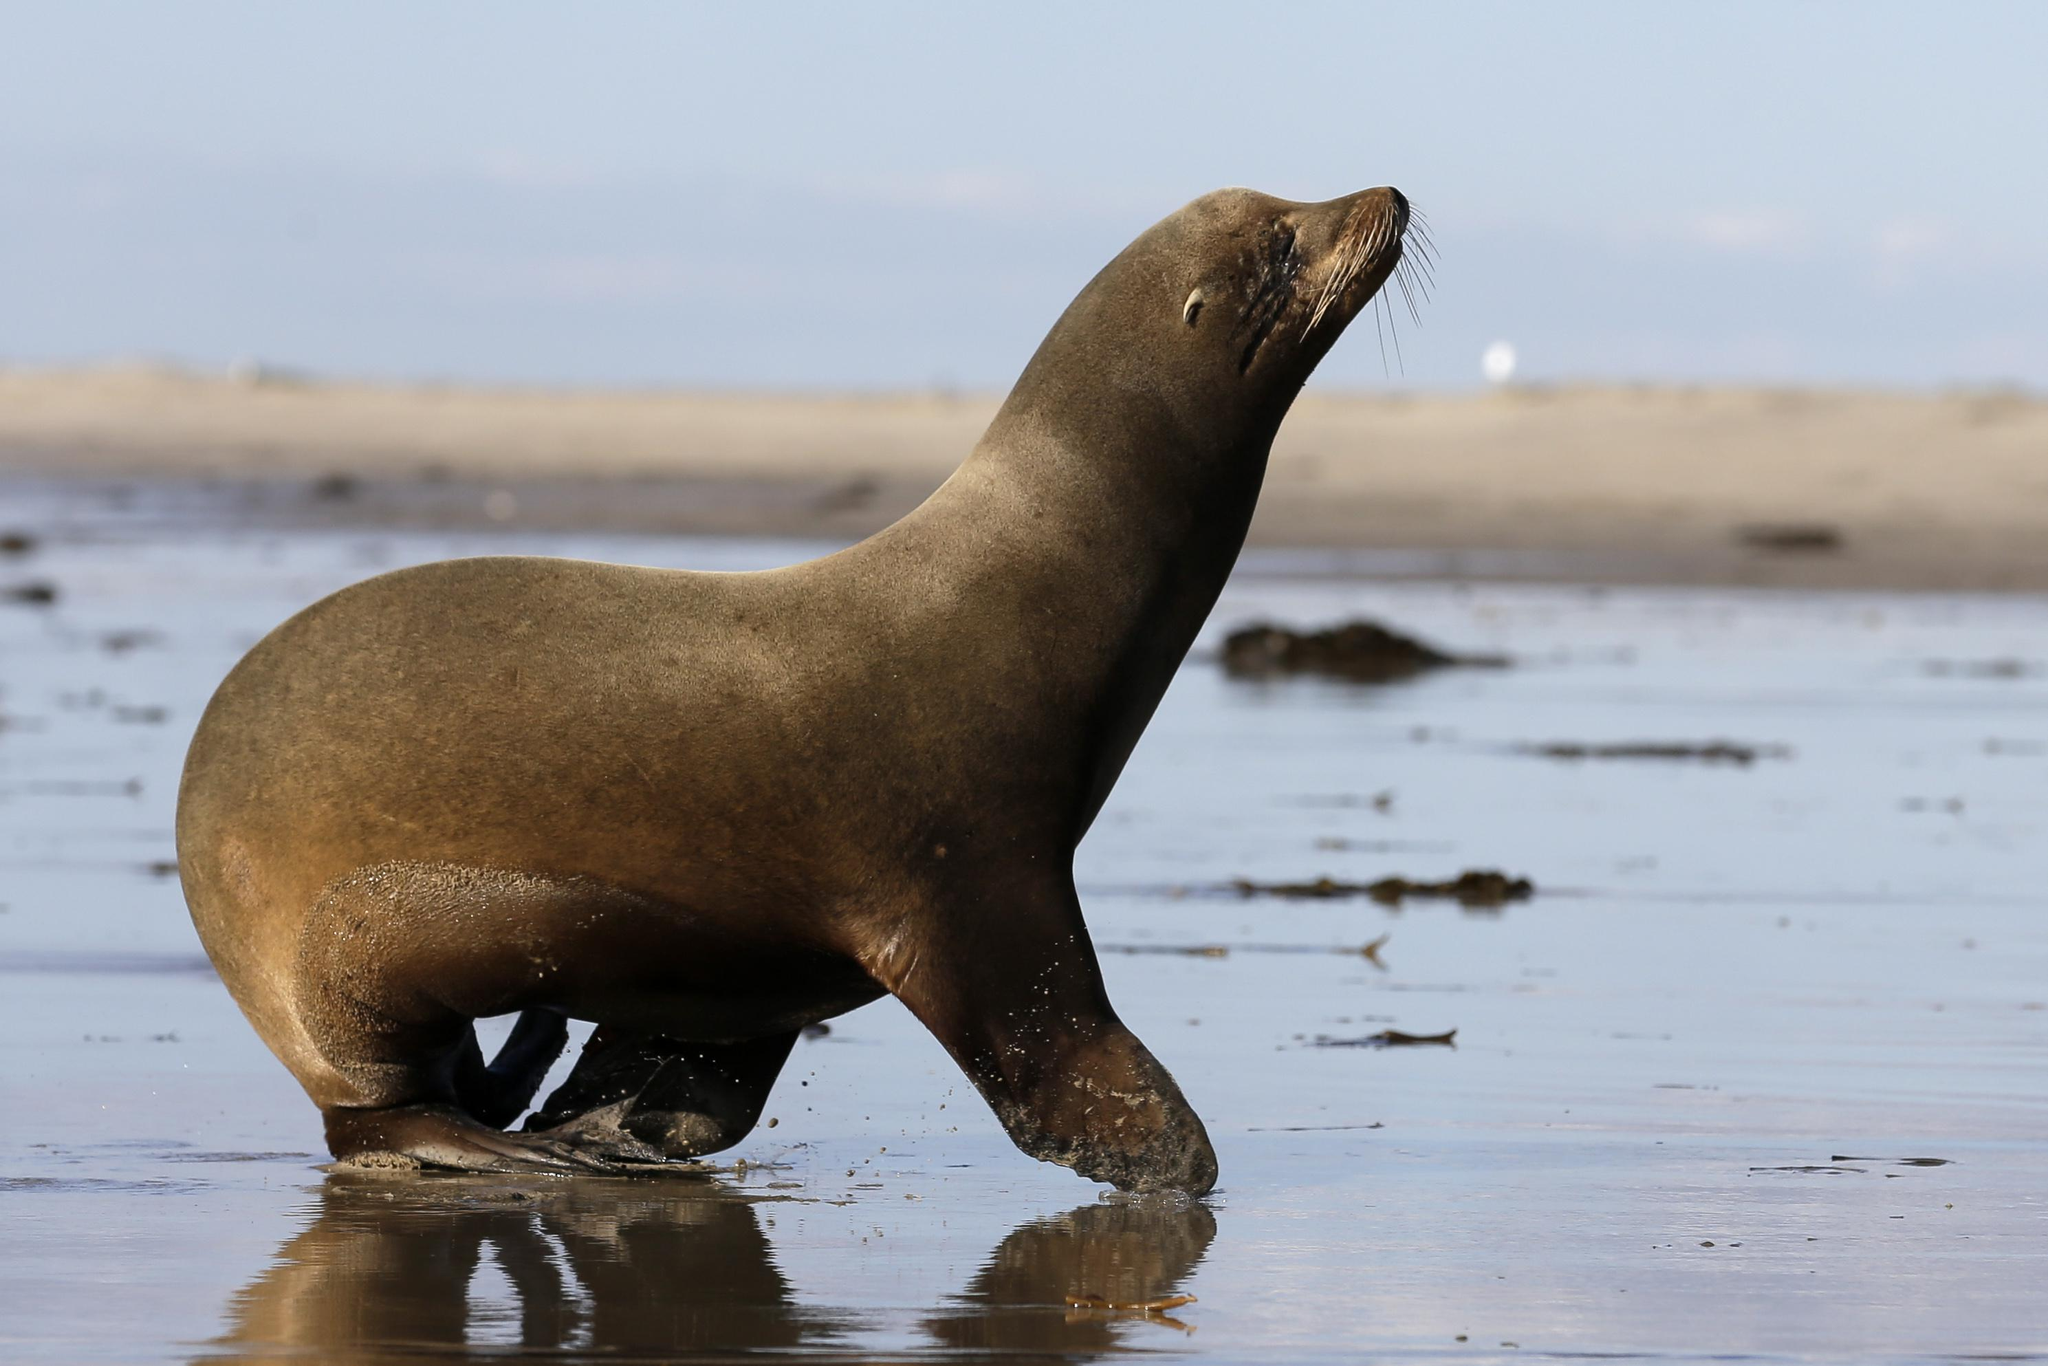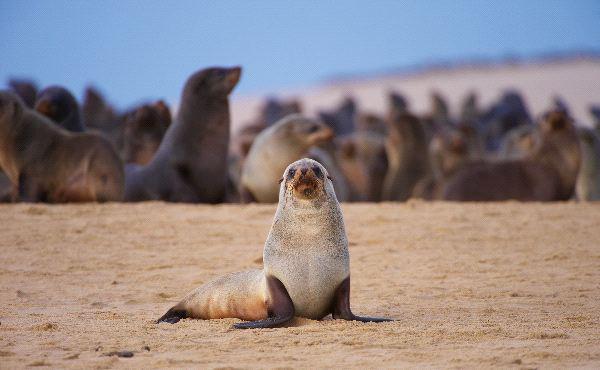The first image is the image on the left, the second image is the image on the right. Evaluate the accuracy of this statement regarding the images: "The left image contains no more than one seal.". Is it true? Answer yes or no. Yes. The first image is the image on the left, the second image is the image on the right. Examine the images to the left and right. Is the description "A single seal is on the beach in the image on the left." accurate? Answer yes or no. Yes. 